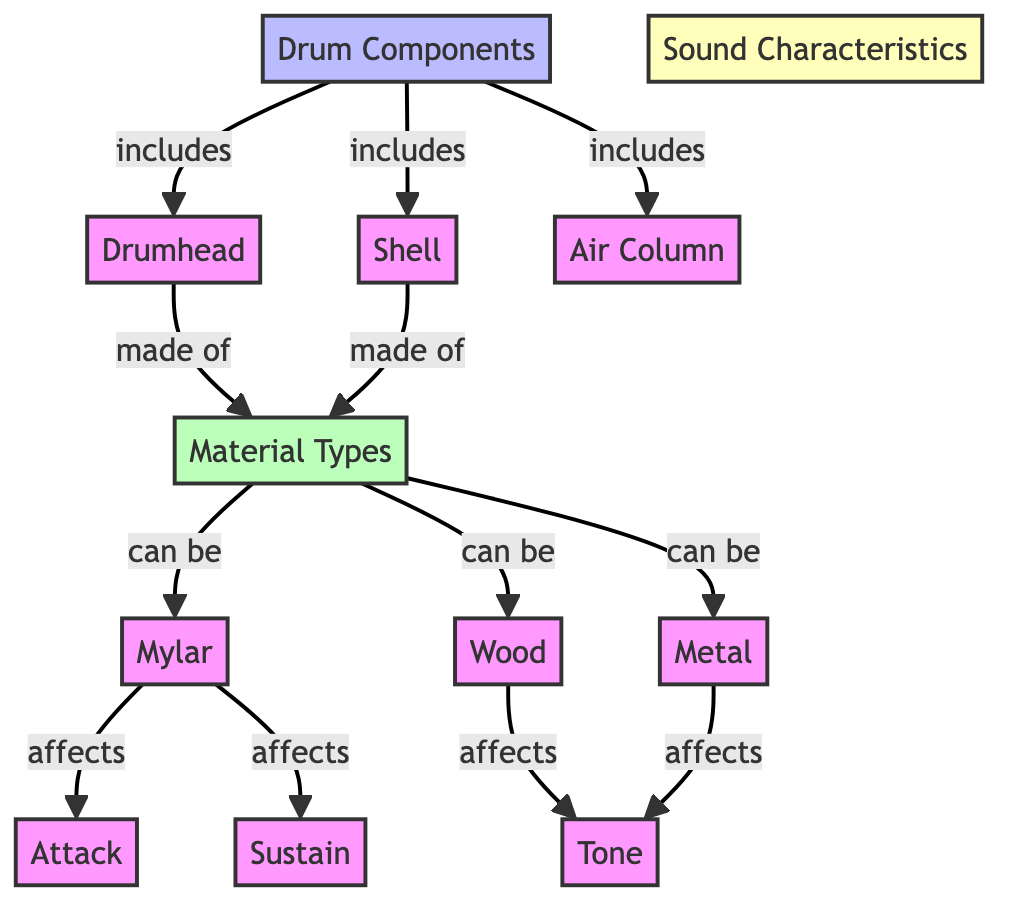What are the three main components of a drum? The diagram shows that the three main components of a drum are the Drumhead, Shell, and Air Column, all connected to the Drum Components node.
Answer: Drumhead, Shell, Air Column Which material types can drumheads be made of? According to the diagram, the material types for drumheads include Mylar, Wood, and Metal, which flow from the Material Types node to the Drumhead node.
Answer: Mylar, Wood, Metal What characteristic does Mylar affect? The diagram indicates that Mylar affects Attack, pointed from Mylar under Material Types to Attack under Sound Characteristics.
Answer: Attack How does Wood affect the drum's sound? The diagram shows that Wood specifically affects Tone, illustrated by an edge from Wood to Tone under Sound Characteristics.
Answer: Tone How many sound characteristics are listed in the diagram? The diagram mentions three sound characteristics: Attack, Sustain, and Tone, which branch off from the Sound Characteristics node.
Answer: Three What relationship exists between Shell and Material Types? The diagram indicates that Shell is made of the material types listed, which means there is a "made of" relationship flowing from Shell to Material Types.
Answer: made of What affects Sustain in the diagram? The diagram does not specify a specific material affecting Sustain; it only connects Sustain directly to the Sound Characteristics node, meaning either of the material types can affect it.
Answer: (No specific material) Which material primarily affects Tone? According to the diagram, Metal is connected directly to Tone, indicating that it primarily affects this sound characteristic.
Answer: Metal 